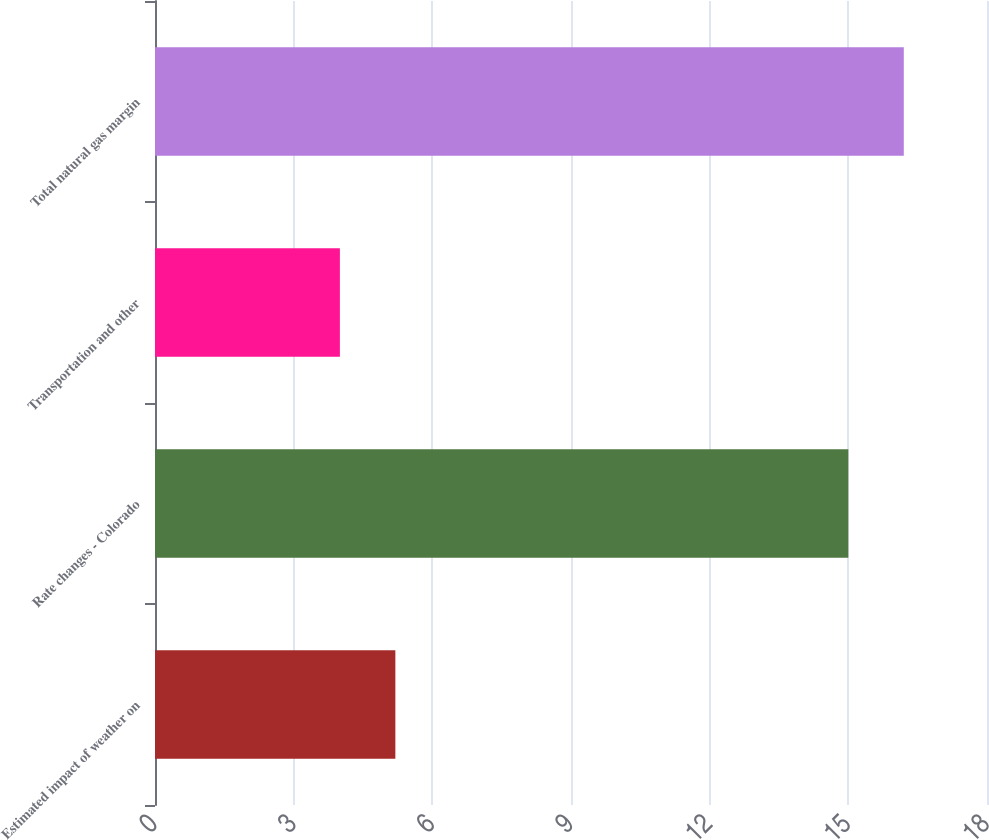Convert chart. <chart><loc_0><loc_0><loc_500><loc_500><bar_chart><fcel>Estimated impact of weather on<fcel>Rate changes - Colorado<fcel>Transportation and other<fcel>Total natural gas margin<nl><fcel>5.2<fcel>15<fcel>4<fcel>16.2<nl></chart> 